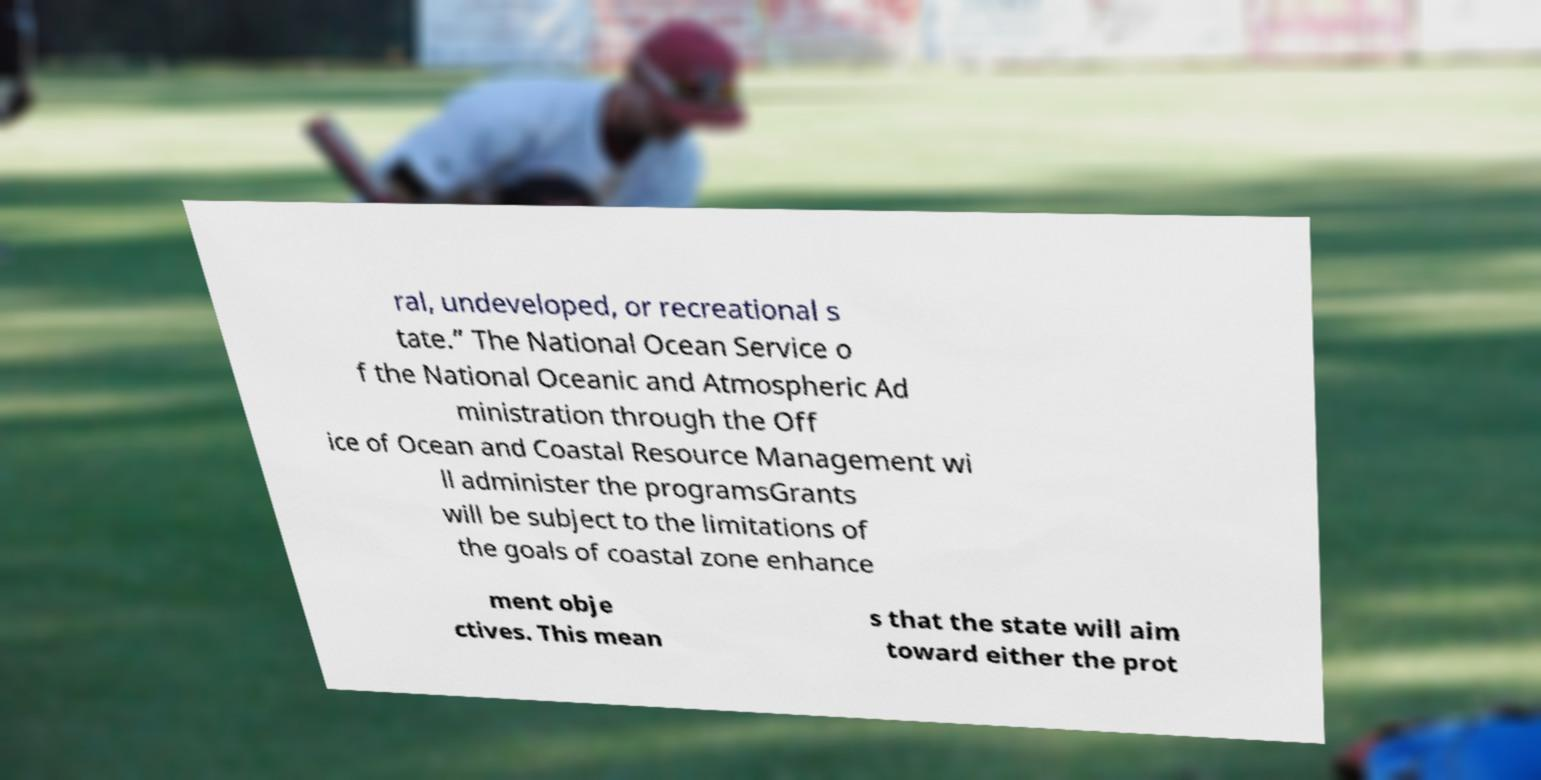I need the written content from this picture converted into text. Can you do that? ral, undeveloped, or recreational s tate.” The National Ocean Service o f the National Oceanic and Atmospheric Ad ministration through the Off ice of Ocean and Coastal Resource Management wi ll administer the programsGrants will be subject to the limitations of the goals of coastal zone enhance ment obje ctives. This mean s that the state will aim toward either the prot 